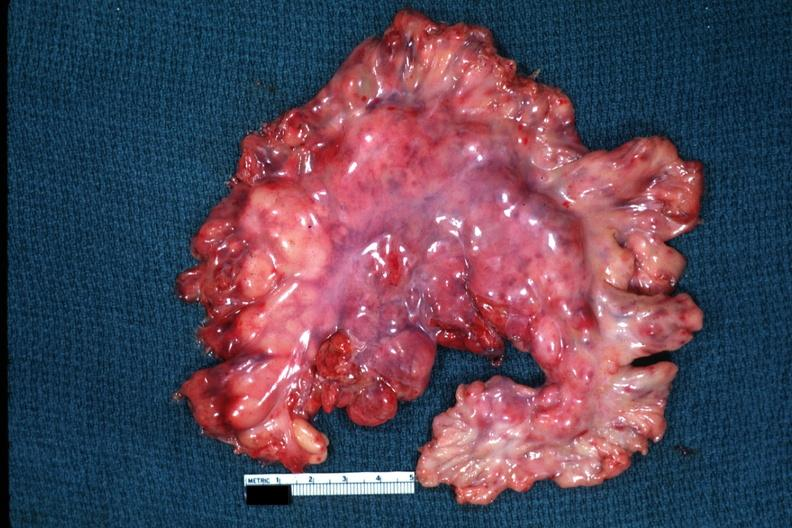what is present?
Answer the question using a single word or phrase. Acute lymphocytic leukemia 